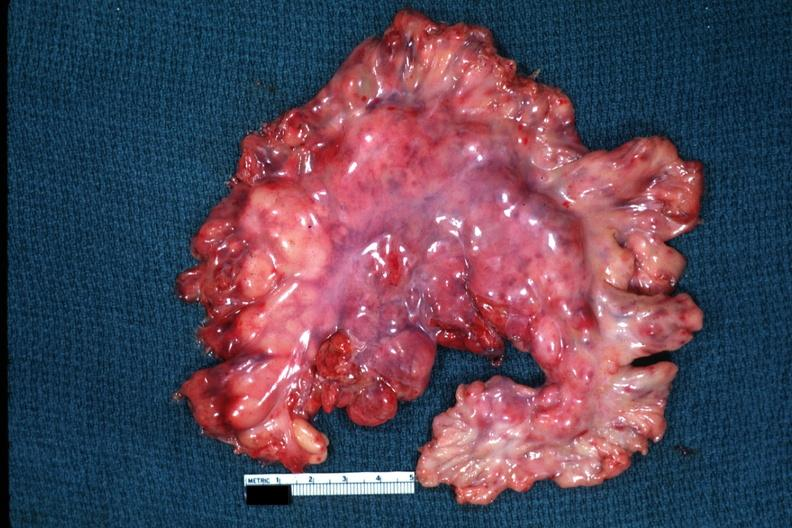what is present?
Answer the question using a single word or phrase. Acute lymphocytic leukemia 